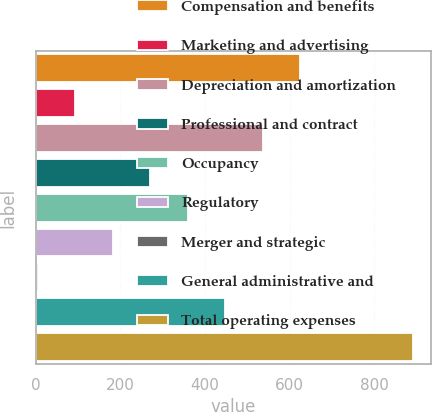Convert chart. <chart><loc_0><loc_0><loc_500><loc_500><bar_chart><fcel>Compensation and benefits<fcel>Marketing and advertising<fcel>Depreciation and amortization<fcel>Professional and contract<fcel>Occupancy<fcel>Regulatory<fcel>Merger and strategic<fcel>General administrative and<fcel>Total operating expenses<nl><fcel>624.9<fcel>92.7<fcel>536.2<fcel>270.1<fcel>358.8<fcel>181.4<fcel>4<fcel>447.5<fcel>891<nl></chart> 